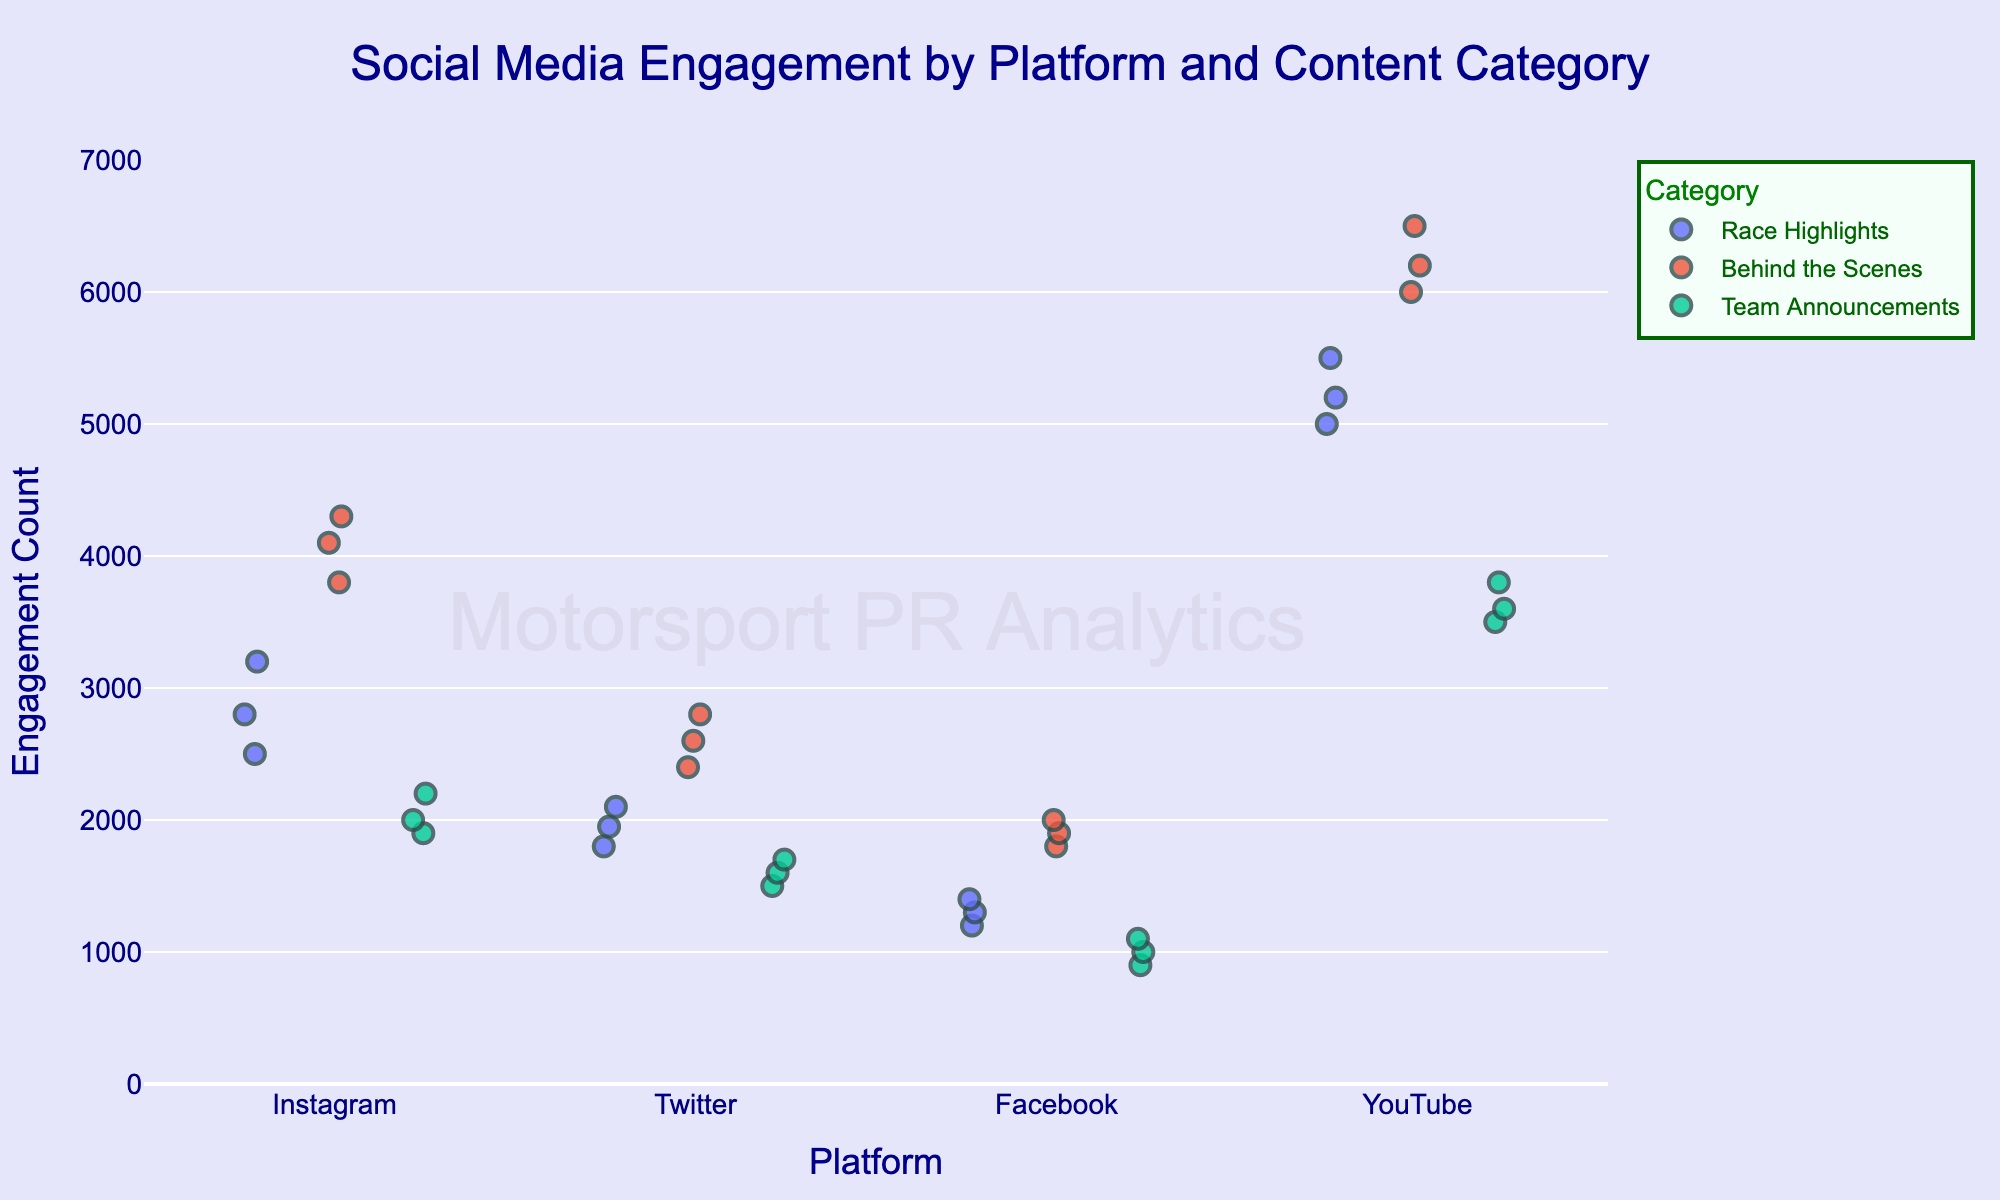What is the title of the strip plot? The title is written at the top center of the plot. By directly reading it, we get the title.
Answer: Social Media Engagement by Platform and Content Category What are the platforms included in the plot? Check the horizontal axis (x-axis) to find the names listed.
Answer: Instagram, Twitter, Facebook, YouTube Which category of PR content on Instagram shows the highest engagement? Look at the data points corresponding to Instagram along the x-axis and observe the y-axis values for maximum.
Answer: Behind the Scenes What is the range of engagement on Twitter for 'Team Announcements'? Identify the data points for 'Team Announcements' on the Twitter section of the x-axis and find the minimum and maximum y-values.
Answer: 1500 to 1700 Which platform has the highest engagement for 'Race Highlights'? Compare the highest y-axis values of 'Race Highlights' across all platforms.
Answer: YouTube How does the engagement for 'Behind the Scenes' on Facebook compare to that on YouTube? Look at the distribution of engagement values for 'Behind the Scenes' on both Facebook and YouTube.
Answer: Lower on Facebook than YouTube What is the average engagement for 'Team Announcements' on Instagram? Sum the engagement values for 'Team Announcements' on Instagram and divide by the number of data points (1900, 2200, 2000).
Answer: 2033.33 Which category has the most consistent engagement across all platforms? Look for the category with the least spread in engagement values across platforms.
Answer: Team Announcements Compare the maximum engagement of 'Behind the Scenes' on Instagram and Twitter. Which is higher? Identify the maximum y-values for 'Behind the Scenes' on both platforms and compare them.
Answer: Instagram Is there any platform where 'Race Highlights' have a lower median engagement than any other content category? Check and compare the median lines or central tendency of 'Race Highlights' to other categories for each platform.
Answer: Yes, Facebook 